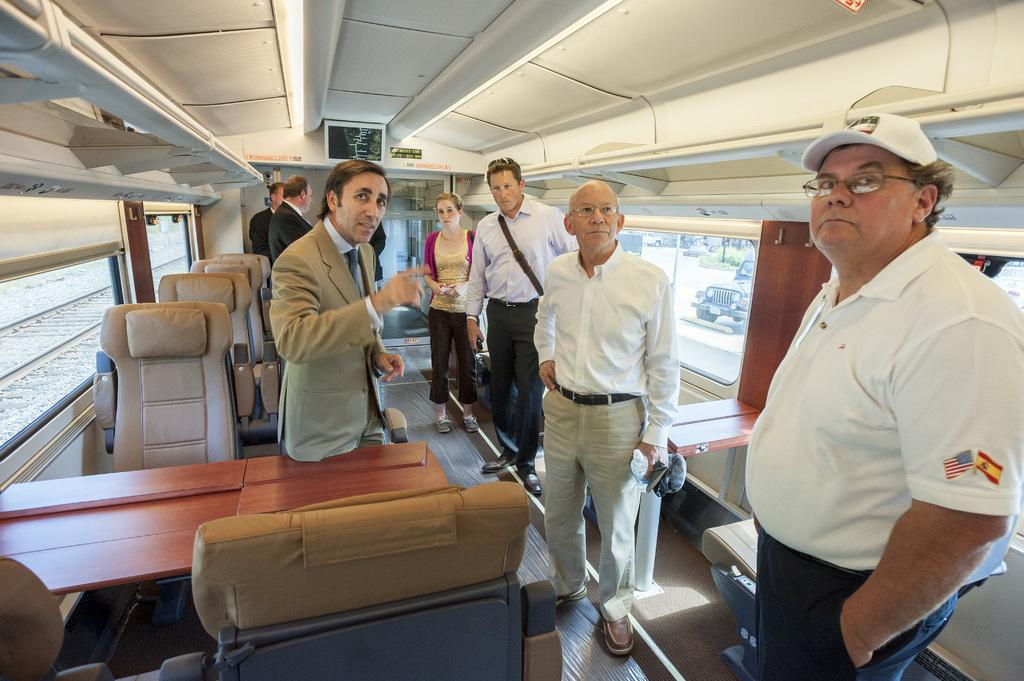What can be seen in the image? There are people standing in the image. Where are the people standing? The people are standing on the floor. What can be seen in the background of the image? There are chairs, tables, the ceiling, windows, a railway track, a vehicle, and other objects visible in the background of the image. How many jellyfish can be seen swimming in the image? There are no jellyfish present in the image; it features people standing on the floor and various objects in the background. 